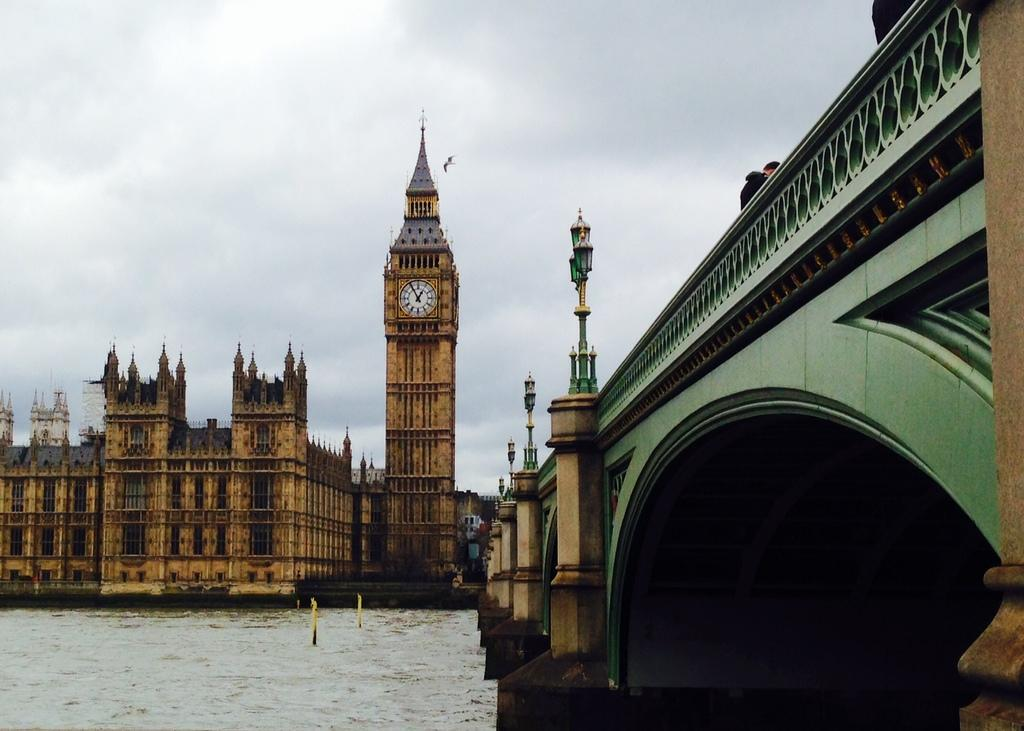What is the primary element present in the image? There is water in the image. What type of structure can be seen crossing the water? There is a green, black, and brown bridge in the image. What else can be seen in the image besides the water and bridge? There are buildings in the image. Can you describe any specific features on the buildings? There is a clock on one of the buildings. What is visible in the background of the image? The sky is visible in the background of the image. How many clovers are floating on the water in the image? There are no clovers present in the image; it features water, a bridge, buildings, and a clock. What is the price of the bridge in the image? The image does not provide any information about the price of the bridge. 